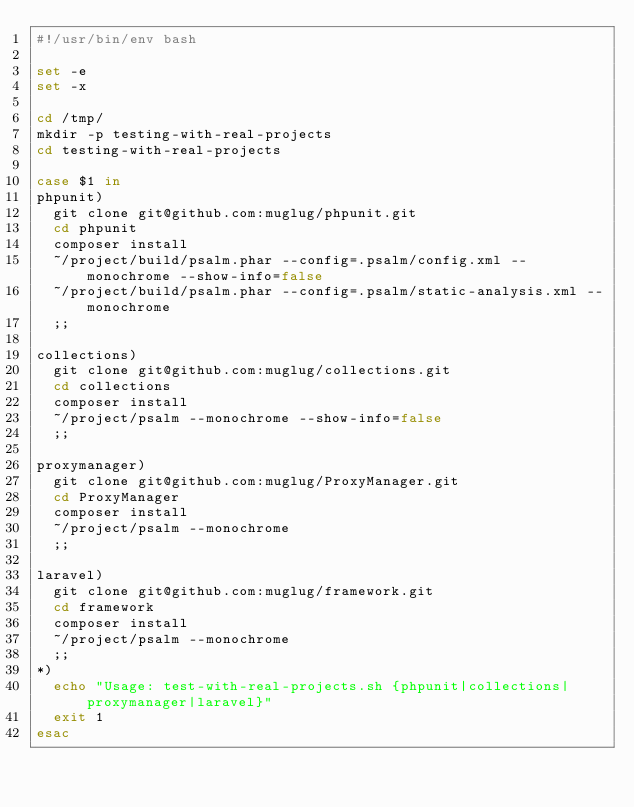<code> <loc_0><loc_0><loc_500><loc_500><_Bash_>#!/usr/bin/env bash

set -e
set -x

cd /tmp/
mkdir -p testing-with-real-projects
cd testing-with-real-projects

case $1 in
phpunit)
	git clone git@github.com:muglug/phpunit.git
	cd phpunit
	composer install
	~/project/build/psalm.phar --config=.psalm/config.xml --monochrome --show-info=false
	~/project/build/psalm.phar --config=.psalm/static-analysis.xml --monochrome
	;;

collections)
	git clone git@github.com:muglug/collections.git
	cd collections
	composer install
	~/project/psalm --monochrome --show-info=false
	;;

proxymanager)
	git clone git@github.com:muglug/ProxyManager.git
	cd ProxyManager
	composer install
	~/project/psalm --monochrome
	;;

laravel)
	git clone git@github.com:muglug/framework.git
	cd framework
	composer install
	~/project/psalm --monochrome
	;;
*)
	echo "Usage: test-with-real-projects.sh {phpunit|collections|proxymanager|laravel}"
	exit 1
esac
</code> 